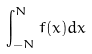Convert formula to latex. <formula><loc_0><loc_0><loc_500><loc_500>\int _ { - N } ^ { N } f ( x ) d x</formula> 